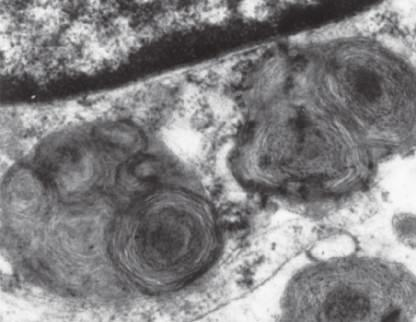what does a portion of a neuron under the electron microscope show?
Answer the question using a single word or phrase. Prominent lysosomes with whorled configurations just below part of the nucleus 